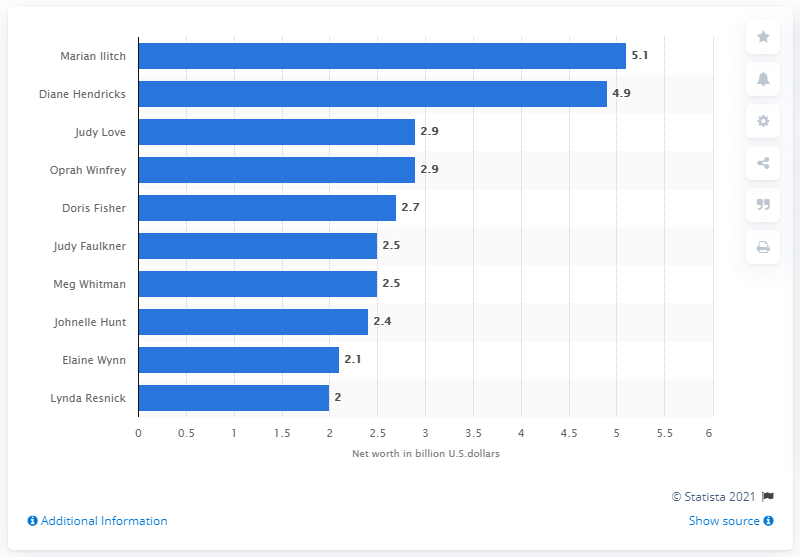Specify some key components in this picture. Oprah Winfrey is the third richest self-made woman billionaire in the United States. Oprah Winfrey has a business partner named Judy Love. In 2017, Marian Ilitch's net worth was estimated to be $5.1 billion dollars. 